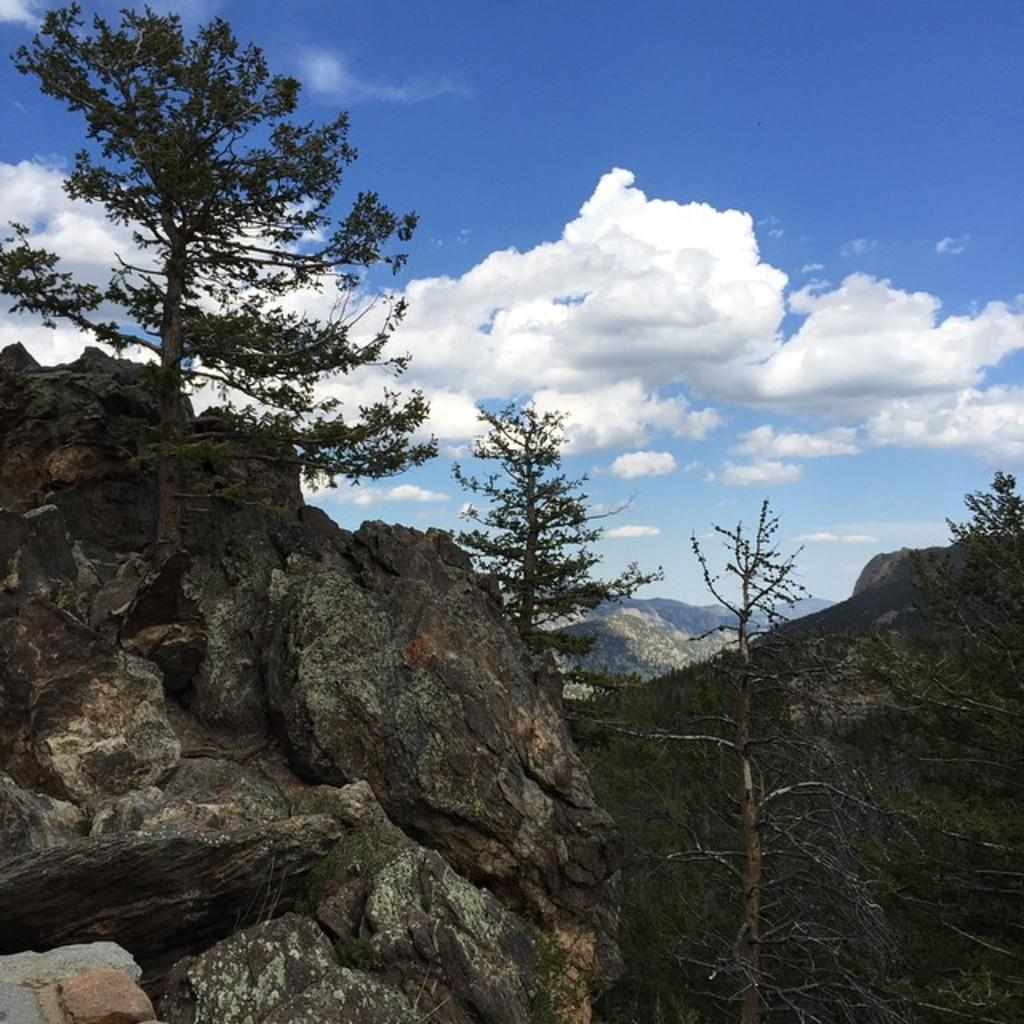What type of natural elements can be seen in the image? There are trees and rocks in the image. What is visible in the background of the image? The sky is visible in the background of the image. What can be observed in the sky? Clouds are present in the sky. How many dolls are sitting on the rocks in the image? There are no dolls present in the image; it features trees, rocks, and a sky with clouds. 